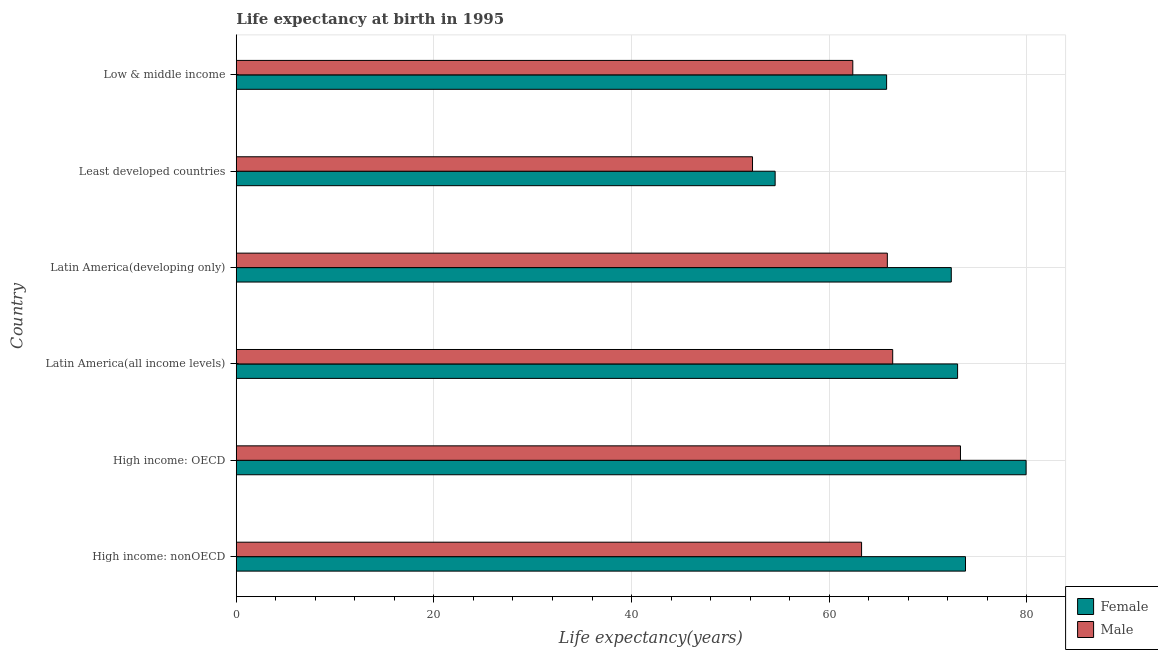How many groups of bars are there?
Make the answer very short. 6. Are the number of bars on each tick of the Y-axis equal?
Give a very brief answer. Yes. What is the label of the 6th group of bars from the top?
Offer a terse response. High income: nonOECD. What is the life expectancy(male) in Least developed countries?
Give a very brief answer. 52.24. Across all countries, what is the maximum life expectancy(male)?
Give a very brief answer. 73.28. Across all countries, what is the minimum life expectancy(female)?
Keep it short and to the point. 54.53. In which country was the life expectancy(female) maximum?
Make the answer very short. High income: OECD. In which country was the life expectancy(male) minimum?
Keep it short and to the point. Least developed countries. What is the total life expectancy(female) in the graph?
Provide a short and direct response. 419.41. What is the difference between the life expectancy(male) in High income: nonOECD and that in Latin America(developing only)?
Offer a terse response. -2.61. What is the difference between the life expectancy(female) in High income: nonOECD and the life expectancy(male) in Latin America(all income levels)?
Your response must be concise. 7.37. What is the average life expectancy(female) per country?
Make the answer very short. 69.9. What is the difference between the life expectancy(female) and life expectancy(male) in Low & middle income?
Your response must be concise. 3.42. In how many countries, is the life expectancy(male) greater than 64 years?
Provide a succinct answer. 3. What is the ratio of the life expectancy(male) in High income: nonOECD to that in Latin America(all income levels)?
Your answer should be compact. 0.95. What is the difference between the highest and the second highest life expectancy(female)?
Ensure brevity in your answer.  6.13. What is the difference between the highest and the lowest life expectancy(male)?
Provide a succinct answer. 21.04. In how many countries, is the life expectancy(male) greater than the average life expectancy(male) taken over all countries?
Your response must be concise. 3. Is the sum of the life expectancy(male) in High income: OECD and Latin America(developing only) greater than the maximum life expectancy(female) across all countries?
Your response must be concise. Yes. How many bars are there?
Provide a succinct answer. 12. Are all the bars in the graph horizontal?
Make the answer very short. Yes. What is the difference between two consecutive major ticks on the X-axis?
Keep it short and to the point. 20. Are the values on the major ticks of X-axis written in scientific E-notation?
Keep it short and to the point. No. Does the graph contain grids?
Your response must be concise. Yes. What is the title of the graph?
Offer a terse response. Life expectancy at birth in 1995. What is the label or title of the X-axis?
Your answer should be very brief. Life expectancy(years). What is the label or title of the Y-axis?
Provide a short and direct response. Country. What is the Life expectancy(years) in Female in High income: nonOECD?
Offer a terse response. 73.79. What is the Life expectancy(years) of Male in High income: nonOECD?
Make the answer very short. 63.28. What is the Life expectancy(years) of Female in High income: OECD?
Offer a terse response. 79.92. What is the Life expectancy(years) of Male in High income: OECD?
Your answer should be very brief. 73.28. What is the Life expectancy(years) of Female in Latin America(all income levels)?
Make the answer very short. 72.99. What is the Life expectancy(years) of Male in Latin America(all income levels)?
Provide a succinct answer. 66.43. What is the Life expectancy(years) in Female in Latin America(developing only)?
Ensure brevity in your answer.  72.35. What is the Life expectancy(years) of Male in Latin America(developing only)?
Offer a very short reply. 65.88. What is the Life expectancy(years) of Female in Least developed countries?
Offer a very short reply. 54.53. What is the Life expectancy(years) in Male in Least developed countries?
Offer a very short reply. 52.24. What is the Life expectancy(years) in Female in Low & middle income?
Offer a very short reply. 65.81. What is the Life expectancy(years) of Male in Low & middle income?
Your answer should be compact. 62.39. Across all countries, what is the maximum Life expectancy(years) of Female?
Keep it short and to the point. 79.92. Across all countries, what is the maximum Life expectancy(years) in Male?
Offer a very short reply. 73.28. Across all countries, what is the minimum Life expectancy(years) in Female?
Your answer should be compact. 54.53. Across all countries, what is the minimum Life expectancy(years) in Male?
Make the answer very short. 52.24. What is the total Life expectancy(years) of Female in the graph?
Offer a very short reply. 419.41. What is the total Life expectancy(years) in Male in the graph?
Provide a succinct answer. 383.5. What is the difference between the Life expectancy(years) of Female in High income: nonOECD and that in High income: OECD?
Provide a short and direct response. -6.13. What is the difference between the Life expectancy(years) in Male in High income: nonOECD and that in High income: OECD?
Your response must be concise. -10.01. What is the difference between the Life expectancy(years) of Female in High income: nonOECD and that in Latin America(all income levels)?
Offer a terse response. 0.8. What is the difference between the Life expectancy(years) of Male in High income: nonOECD and that in Latin America(all income levels)?
Your answer should be compact. -3.15. What is the difference between the Life expectancy(years) of Female in High income: nonOECD and that in Latin America(developing only)?
Ensure brevity in your answer.  1.44. What is the difference between the Life expectancy(years) of Male in High income: nonOECD and that in Latin America(developing only)?
Your response must be concise. -2.61. What is the difference between the Life expectancy(years) of Female in High income: nonOECD and that in Least developed countries?
Give a very brief answer. 19.26. What is the difference between the Life expectancy(years) in Male in High income: nonOECD and that in Least developed countries?
Give a very brief answer. 11.04. What is the difference between the Life expectancy(years) in Female in High income: nonOECD and that in Low & middle income?
Provide a succinct answer. 7.98. What is the difference between the Life expectancy(years) of Male in High income: nonOECD and that in Low & middle income?
Offer a terse response. 0.89. What is the difference between the Life expectancy(years) of Female in High income: OECD and that in Latin America(all income levels)?
Provide a short and direct response. 6.93. What is the difference between the Life expectancy(years) of Male in High income: OECD and that in Latin America(all income levels)?
Your answer should be compact. 6.86. What is the difference between the Life expectancy(years) of Female in High income: OECD and that in Latin America(developing only)?
Offer a terse response. 7.57. What is the difference between the Life expectancy(years) of Male in High income: OECD and that in Latin America(developing only)?
Your answer should be very brief. 7.4. What is the difference between the Life expectancy(years) in Female in High income: OECD and that in Least developed countries?
Keep it short and to the point. 25.39. What is the difference between the Life expectancy(years) of Male in High income: OECD and that in Least developed countries?
Make the answer very short. 21.04. What is the difference between the Life expectancy(years) of Female in High income: OECD and that in Low & middle income?
Provide a short and direct response. 14.11. What is the difference between the Life expectancy(years) in Male in High income: OECD and that in Low & middle income?
Provide a succinct answer. 10.9. What is the difference between the Life expectancy(years) of Female in Latin America(all income levels) and that in Latin America(developing only)?
Your response must be concise. 0.64. What is the difference between the Life expectancy(years) of Male in Latin America(all income levels) and that in Latin America(developing only)?
Offer a terse response. 0.54. What is the difference between the Life expectancy(years) in Female in Latin America(all income levels) and that in Least developed countries?
Make the answer very short. 18.46. What is the difference between the Life expectancy(years) in Male in Latin America(all income levels) and that in Least developed countries?
Your answer should be compact. 14.19. What is the difference between the Life expectancy(years) in Female in Latin America(all income levels) and that in Low & middle income?
Provide a short and direct response. 7.18. What is the difference between the Life expectancy(years) in Male in Latin America(all income levels) and that in Low & middle income?
Give a very brief answer. 4.04. What is the difference between the Life expectancy(years) in Female in Latin America(developing only) and that in Least developed countries?
Offer a terse response. 17.82. What is the difference between the Life expectancy(years) in Male in Latin America(developing only) and that in Least developed countries?
Ensure brevity in your answer.  13.64. What is the difference between the Life expectancy(years) of Female in Latin America(developing only) and that in Low & middle income?
Your answer should be compact. 6.54. What is the difference between the Life expectancy(years) in Male in Latin America(developing only) and that in Low & middle income?
Ensure brevity in your answer.  3.5. What is the difference between the Life expectancy(years) of Female in Least developed countries and that in Low & middle income?
Provide a succinct answer. -11.28. What is the difference between the Life expectancy(years) of Male in Least developed countries and that in Low & middle income?
Keep it short and to the point. -10.15. What is the difference between the Life expectancy(years) of Female in High income: nonOECD and the Life expectancy(years) of Male in High income: OECD?
Keep it short and to the point. 0.51. What is the difference between the Life expectancy(years) in Female in High income: nonOECD and the Life expectancy(years) in Male in Latin America(all income levels)?
Keep it short and to the point. 7.37. What is the difference between the Life expectancy(years) of Female in High income: nonOECD and the Life expectancy(years) of Male in Latin America(developing only)?
Your answer should be compact. 7.91. What is the difference between the Life expectancy(years) in Female in High income: nonOECD and the Life expectancy(years) in Male in Least developed countries?
Your answer should be very brief. 21.55. What is the difference between the Life expectancy(years) in Female in High income: nonOECD and the Life expectancy(years) in Male in Low & middle income?
Your answer should be compact. 11.41. What is the difference between the Life expectancy(years) of Female in High income: OECD and the Life expectancy(years) of Male in Latin America(all income levels)?
Provide a short and direct response. 13.5. What is the difference between the Life expectancy(years) of Female in High income: OECD and the Life expectancy(years) of Male in Latin America(developing only)?
Your answer should be compact. 14.04. What is the difference between the Life expectancy(years) in Female in High income: OECD and the Life expectancy(years) in Male in Least developed countries?
Your response must be concise. 27.68. What is the difference between the Life expectancy(years) in Female in High income: OECD and the Life expectancy(years) in Male in Low & middle income?
Make the answer very short. 17.54. What is the difference between the Life expectancy(years) of Female in Latin America(all income levels) and the Life expectancy(years) of Male in Latin America(developing only)?
Offer a terse response. 7.11. What is the difference between the Life expectancy(years) of Female in Latin America(all income levels) and the Life expectancy(years) of Male in Least developed countries?
Provide a short and direct response. 20.75. What is the difference between the Life expectancy(years) in Female in Latin America(all income levels) and the Life expectancy(years) in Male in Low & middle income?
Offer a terse response. 10.6. What is the difference between the Life expectancy(years) of Female in Latin America(developing only) and the Life expectancy(years) of Male in Least developed countries?
Offer a very short reply. 20.11. What is the difference between the Life expectancy(years) of Female in Latin America(developing only) and the Life expectancy(years) of Male in Low & middle income?
Your answer should be very brief. 9.97. What is the difference between the Life expectancy(years) in Female in Least developed countries and the Life expectancy(years) in Male in Low & middle income?
Provide a succinct answer. -7.86. What is the average Life expectancy(years) of Female per country?
Give a very brief answer. 69.9. What is the average Life expectancy(years) in Male per country?
Make the answer very short. 63.92. What is the difference between the Life expectancy(years) in Female and Life expectancy(years) in Male in High income: nonOECD?
Offer a very short reply. 10.52. What is the difference between the Life expectancy(years) in Female and Life expectancy(years) in Male in High income: OECD?
Provide a short and direct response. 6.64. What is the difference between the Life expectancy(years) of Female and Life expectancy(years) of Male in Latin America(all income levels)?
Your answer should be compact. 6.57. What is the difference between the Life expectancy(years) of Female and Life expectancy(years) of Male in Latin America(developing only)?
Offer a very short reply. 6.47. What is the difference between the Life expectancy(years) of Female and Life expectancy(years) of Male in Least developed countries?
Your answer should be very brief. 2.29. What is the difference between the Life expectancy(years) in Female and Life expectancy(years) in Male in Low & middle income?
Your answer should be compact. 3.42. What is the ratio of the Life expectancy(years) of Female in High income: nonOECD to that in High income: OECD?
Make the answer very short. 0.92. What is the ratio of the Life expectancy(years) in Male in High income: nonOECD to that in High income: OECD?
Provide a short and direct response. 0.86. What is the ratio of the Life expectancy(years) in Male in High income: nonOECD to that in Latin America(all income levels)?
Offer a terse response. 0.95. What is the ratio of the Life expectancy(years) in Female in High income: nonOECD to that in Latin America(developing only)?
Give a very brief answer. 1.02. What is the ratio of the Life expectancy(years) of Male in High income: nonOECD to that in Latin America(developing only)?
Make the answer very short. 0.96. What is the ratio of the Life expectancy(years) in Female in High income: nonOECD to that in Least developed countries?
Your answer should be compact. 1.35. What is the ratio of the Life expectancy(years) of Male in High income: nonOECD to that in Least developed countries?
Offer a very short reply. 1.21. What is the ratio of the Life expectancy(years) in Female in High income: nonOECD to that in Low & middle income?
Offer a very short reply. 1.12. What is the ratio of the Life expectancy(years) in Male in High income: nonOECD to that in Low & middle income?
Offer a very short reply. 1.01. What is the ratio of the Life expectancy(years) of Female in High income: OECD to that in Latin America(all income levels)?
Make the answer very short. 1.09. What is the ratio of the Life expectancy(years) of Male in High income: OECD to that in Latin America(all income levels)?
Your response must be concise. 1.1. What is the ratio of the Life expectancy(years) of Female in High income: OECD to that in Latin America(developing only)?
Make the answer very short. 1.1. What is the ratio of the Life expectancy(years) of Male in High income: OECD to that in Latin America(developing only)?
Give a very brief answer. 1.11. What is the ratio of the Life expectancy(years) in Female in High income: OECD to that in Least developed countries?
Offer a very short reply. 1.47. What is the ratio of the Life expectancy(years) in Male in High income: OECD to that in Least developed countries?
Ensure brevity in your answer.  1.4. What is the ratio of the Life expectancy(years) in Female in High income: OECD to that in Low & middle income?
Keep it short and to the point. 1.21. What is the ratio of the Life expectancy(years) of Male in High income: OECD to that in Low & middle income?
Offer a terse response. 1.17. What is the ratio of the Life expectancy(years) in Female in Latin America(all income levels) to that in Latin America(developing only)?
Your response must be concise. 1.01. What is the ratio of the Life expectancy(years) of Male in Latin America(all income levels) to that in Latin America(developing only)?
Offer a very short reply. 1.01. What is the ratio of the Life expectancy(years) of Female in Latin America(all income levels) to that in Least developed countries?
Give a very brief answer. 1.34. What is the ratio of the Life expectancy(years) of Male in Latin America(all income levels) to that in Least developed countries?
Keep it short and to the point. 1.27. What is the ratio of the Life expectancy(years) of Female in Latin America(all income levels) to that in Low & middle income?
Your answer should be very brief. 1.11. What is the ratio of the Life expectancy(years) in Male in Latin America(all income levels) to that in Low & middle income?
Keep it short and to the point. 1.06. What is the ratio of the Life expectancy(years) in Female in Latin America(developing only) to that in Least developed countries?
Offer a terse response. 1.33. What is the ratio of the Life expectancy(years) of Male in Latin America(developing only) to that in Least developed countries?
Offer a terse response. 1.26. What is the ratio of the Life expectancy(years) of Female in Latin America(developing only) to that in Low & middle income?
Keep it short and to the point. 1.1. What is the ratio of the Life expectancy(years) of Male in Latin America(developing only) to that in Low & middle income?
Ensure brevity in your answer.  1.06. What is the ratio of the Life expectancy(years) in Female in Least developed countries to that in Low & middle income?
Your answer should be compact. 0.83. What is the ratio of the Life expectancy(years) in Male in Least developed countries to that in Low & middle income?
Your answer should be very brief. 0.84. What is the difference between the highest and the second highest Life expectancy(years) of Female?
Ensure brevity in your answer.  6.13. What is the difference between the highest and the second highest Life expectancy(years) in Male?
Provide a short and direct response. 6.86. What is the difference between the highest and the lowest Life expectancy(years) in Female?
Your answer should be compact. 25.39. What is the difference between the highest and the lowest Life expectancy(years) of Male?
Provide a succinct answer. 21.04. 